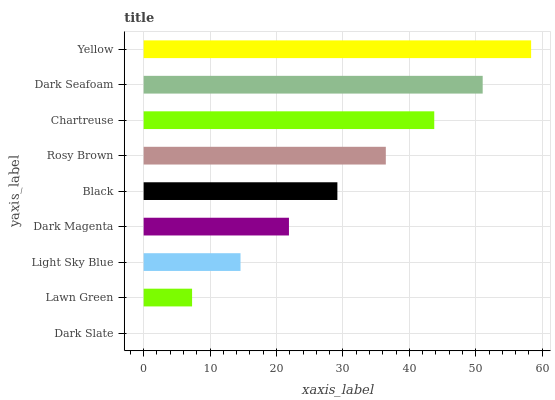Is Dark Slate the minimum?
Answer yes or no. Yes. Is Yellow the maximum?
Answer yes or no. Yes. Is Lawn Green the minimum?
Answer yes or no. No. Is Lawn Green the maximum?
Answer yes or no. No. Is Lawn Green greater than Dark Slate?
Answer yes or no. Yes. Is Dark Slate less than Lawn Green?
Answer yes or no. Yes. Is Dark Slate greater than Lawn Green?
Answer yes or no. No. Is Lawn Green less than Dark Slate?
Answer yes or no. No. Is Black the high median?
Answer yes or no. Yes. Is Black the low median?
Answer yes or no. Yes. Is Lawn Green the high median?
Answer yes or no. No. Is Yellow the low median?
Answer yes or no. No. 